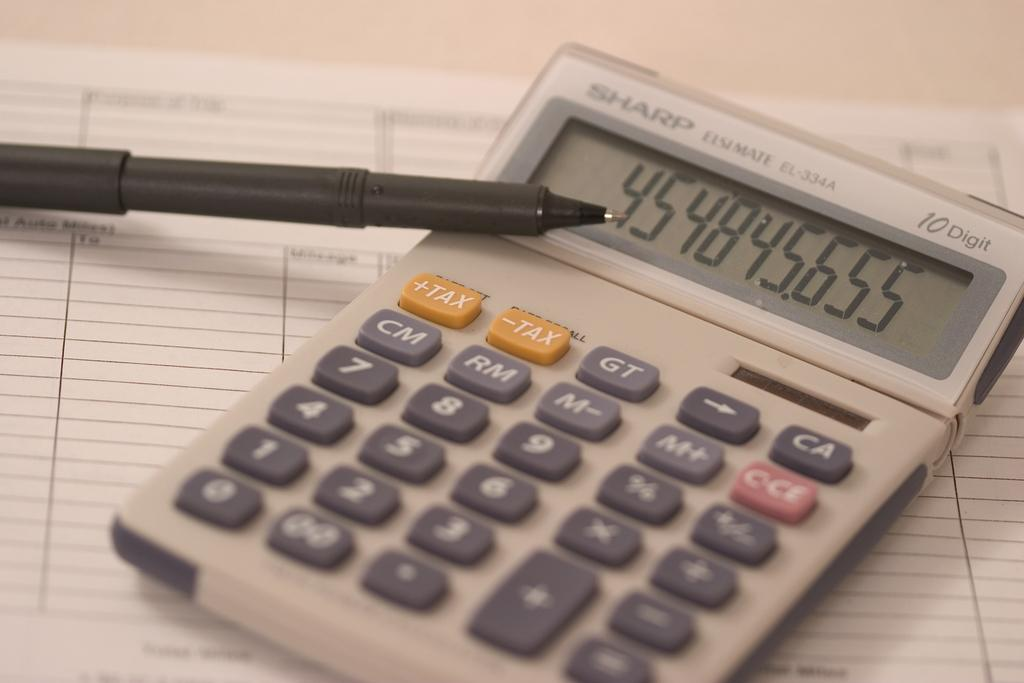Provide a one-sentence caption for the provided image. A long string of numbers appear on a Sharp calculator that is sitting on a blank form. 